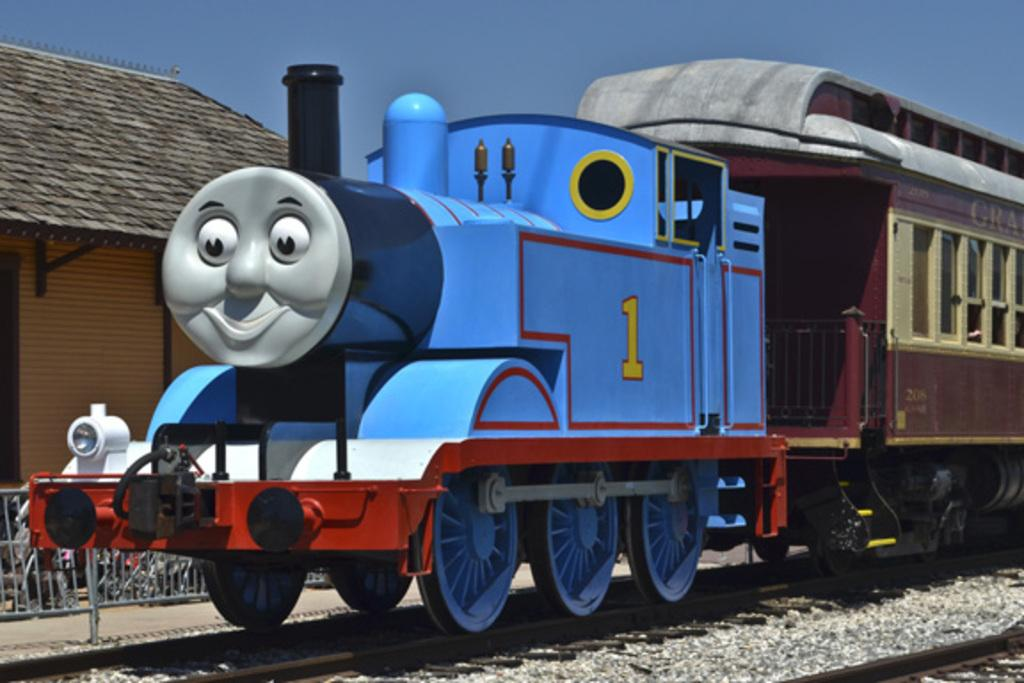<image>
Offer a succinct explanation of the picture presented. a toy train with the number 1 sits on the tracks 